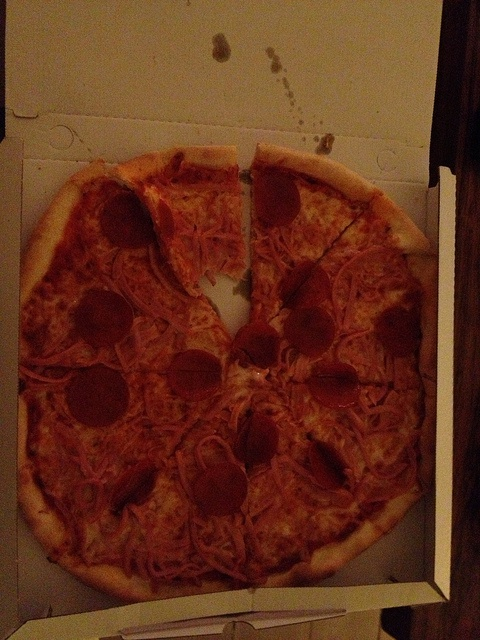Describe the objects in this image and their specific colors. I can see pizza in black, maroon, and brown tones, pizza in black, maroon, and brown tones, and pizza in black, maroon, and brown tones in this image. 